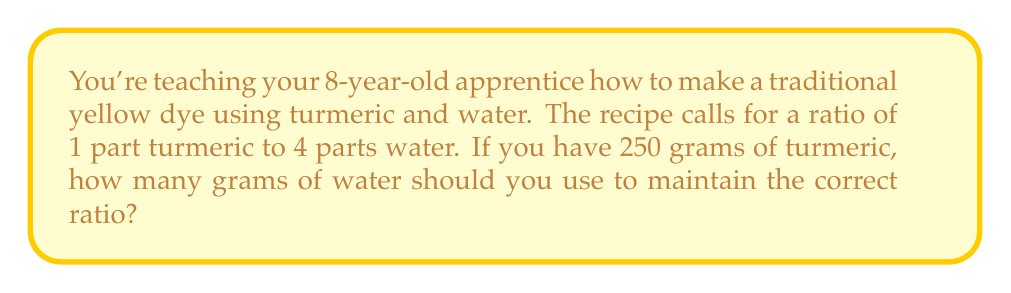What is the answer to this math problem? Let's approach this step-by-step:

1) The ratio of turmeric to water is 1:4. This means for every 1 part of turmeric, we need 4 parts of water.

2) We can express this as a proportion:

   $$\frac{\text{Turmeric}}{\text{Water}} = \frac{1}{4}$$

3) We know we have 250 grams of turmeric. Let's call the amount of water we need $x$ grams. We can set up the equation:

   $$\frac{250}{x} = \frac{1}{4}$$

4) To solve for $x$, we can cross-multiply:

   $$250 \cdot 4 = 1 \cdot x$$

5) Simplify:

   $$1000 = x$$

6) Therefore, we need 1000 grams of water.

7) To check: $\frac{250}{1000} = \frac{1}{4}$, which confirms our ratio is correct.
Answer: 1000 grams 